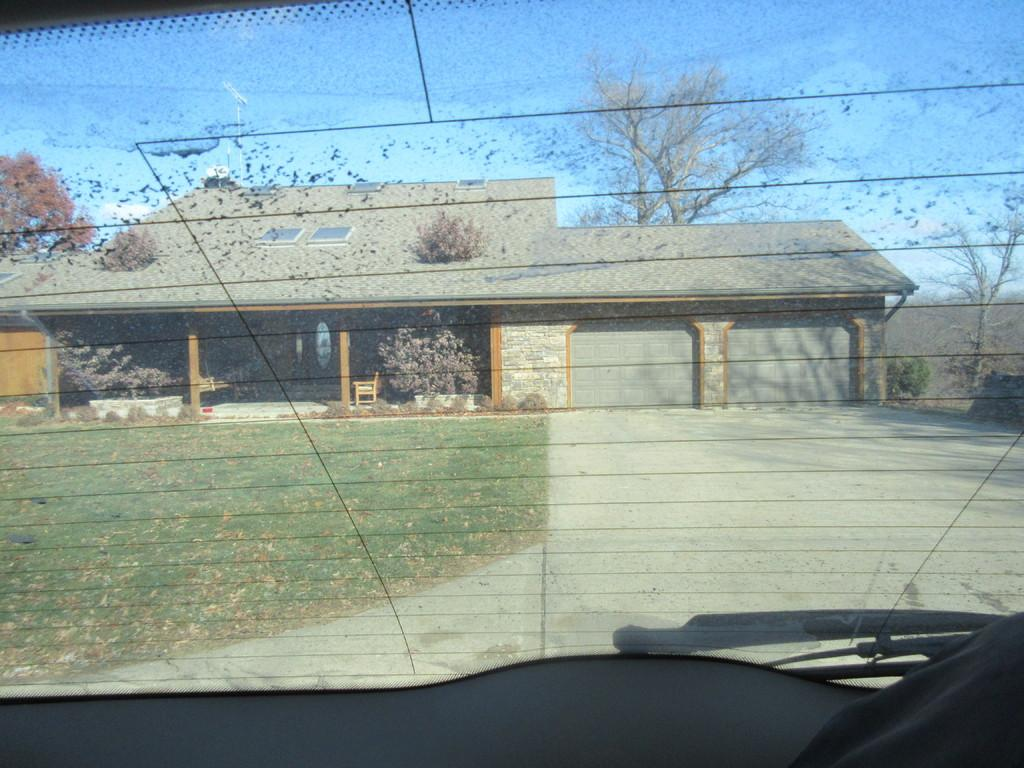What is the main subject of the image? There is a car in the image. What part of the car is visible in the image? The car's back window is visible. What can be seen through the car's back window? Grass, a house, trees, and the blue sky are visible through the car's back window. What type of soup is being served on the ship in the image? There is no ship or soup present in the image; it features a car with a visible back window. 